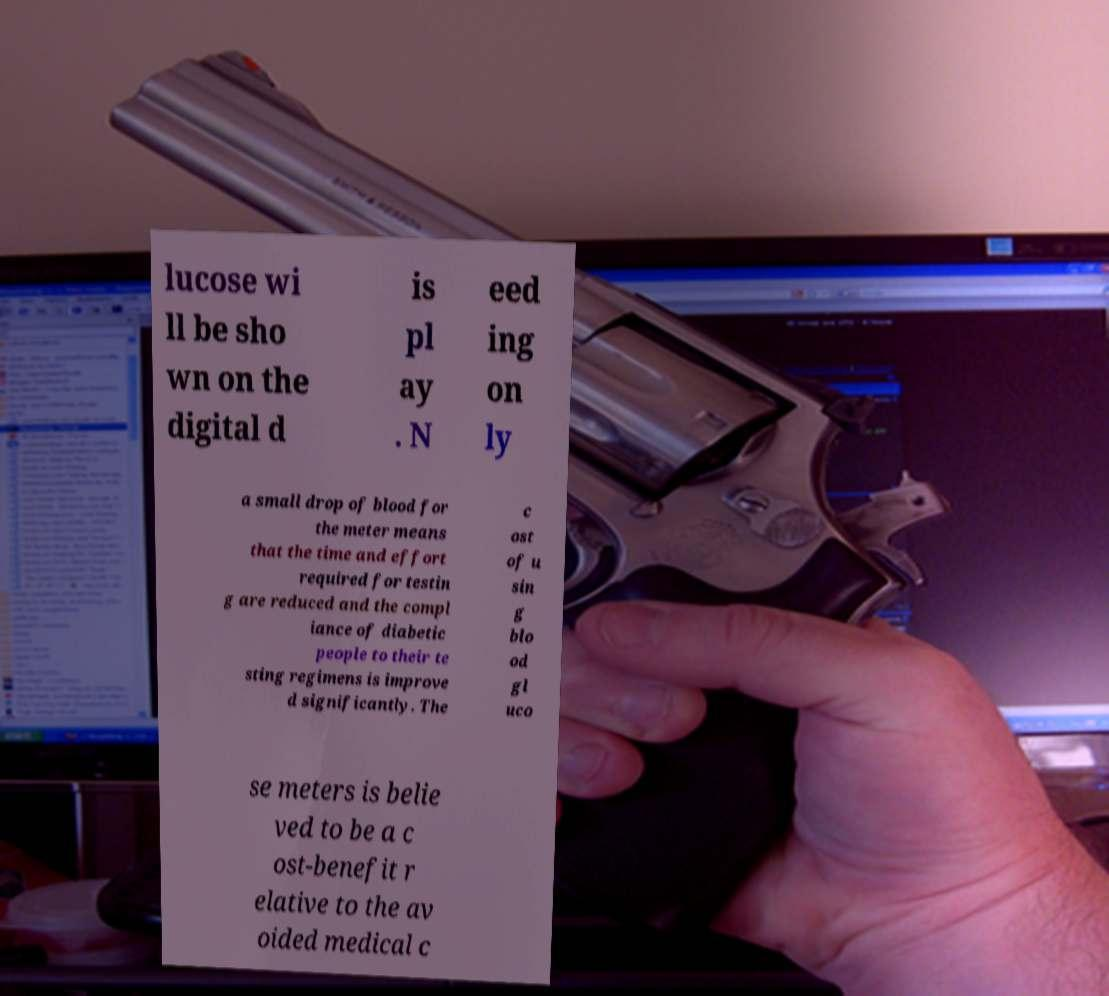There's text embedded in this image that I need extracted. Can you transcribe it verbatim? lucose wi ll be sho wn on the digital d is pl ay . N eed ing on ly a small drop of blood for the meter means that the time and effort required for testin g are reduced and the compl iance of diabetic people to their te sting regimens is improve d significantly. The c ost of u sin g blo od gl uco se meters is belie ved to be a c ost-benefit r elative to the av oided medical c 